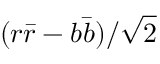<formula> <loc_0><loc_0><loc_500><loc_500>( r { \bar { r } } - b { \bar { b } } ) / { \sqrt { 2 } }</formula> 